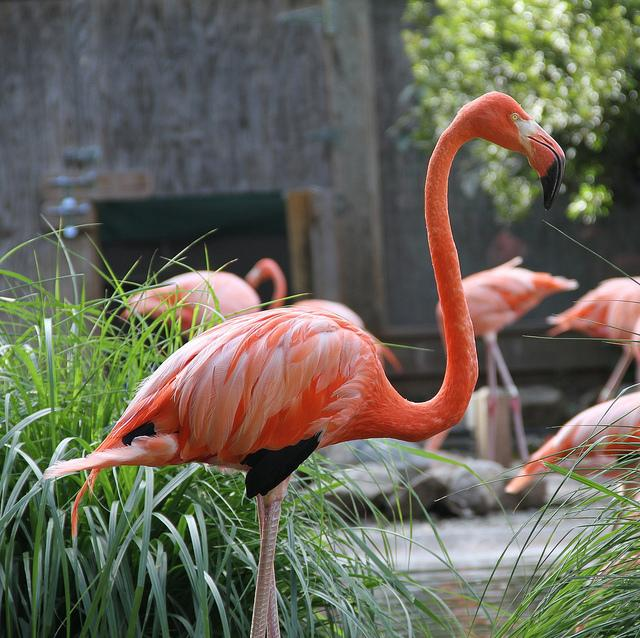How many birds are in focus? one 